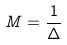Convert formula to latex. <formula><loc_0><loc_0><loc_500><loc_500>M = \frac { 1 } { \Delta }</formula> 